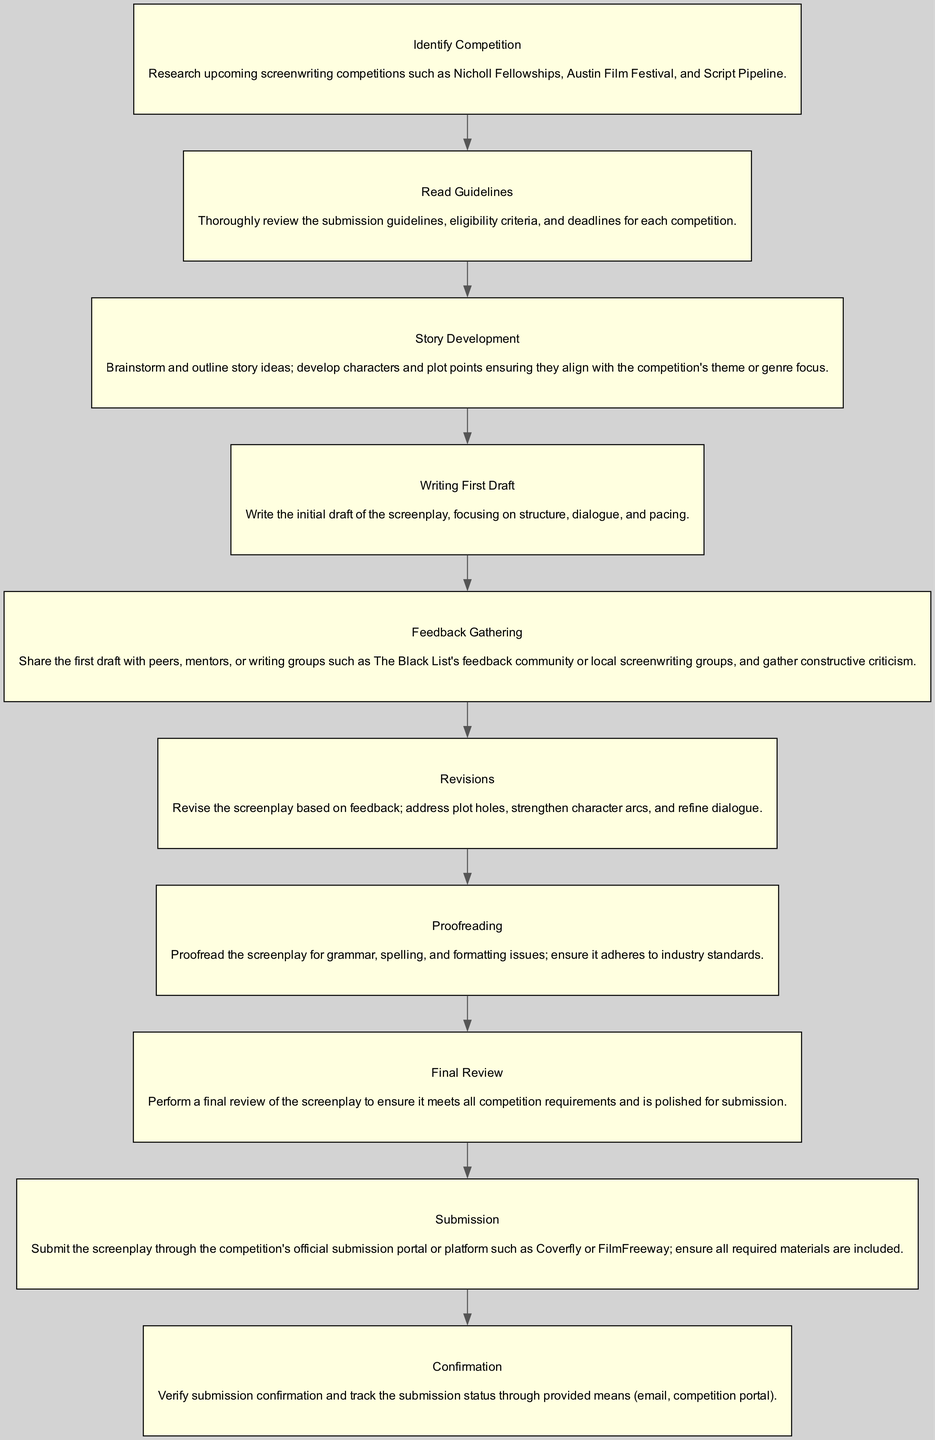What is the first step in the workflow? The first step listed in the diagram is "Identify Competition," which involves researching upcoming screenwriting competitions.
Answer: Identify Competition How many steps are in the workflow? By counting the listed steps in the diagram, there are ten distinct steps in total.
Answer: 10 What follows the "Writing First Draft" step? The step that immediately follows "Writing First Draft" is "Feedback Gathering," indicating that gathering feedback comes after the initial draft is completed.
Answer: Feedback Gathering What is the final step in the diagram? The last step indicated in the diagram is "Confirmation," where you verify the submission confirmation and track the status.
Answer: Confirmation Which step is directly related to polishing the screenplay? The step that deals with polishing the screenplay is "Final Review," which ensures the screenplay is polished and meets competition requirements.
Answer: Final Review What criterion is reviewed after "Read Guidelines"? The next step after "Read Guidelines" is "Story Development," showing that after understanding the guidelines, you move on to developing your story.
Answer: Story Development What are some sources to receive feedback according to the diagram? The diagram mentions sharing the first draft with peers, mentors, or writing groups as sources for feedback.
Answer: Peers, mentors, writing groups In which step is grammar and spelling checked? The step dedicated to checking grammar and spelling is "Proofreading," which specifically focuses on ensuring written standards are met.
Answer: Proofreading What is the focus of the "Revisions" step? The "Revisions" step focuses on addressing plot holes, strengthening character arcs, and refining dialogue based on earlier feedback.
Answer: Addressing plot holes, strengthening character arcs, refining dialogue 